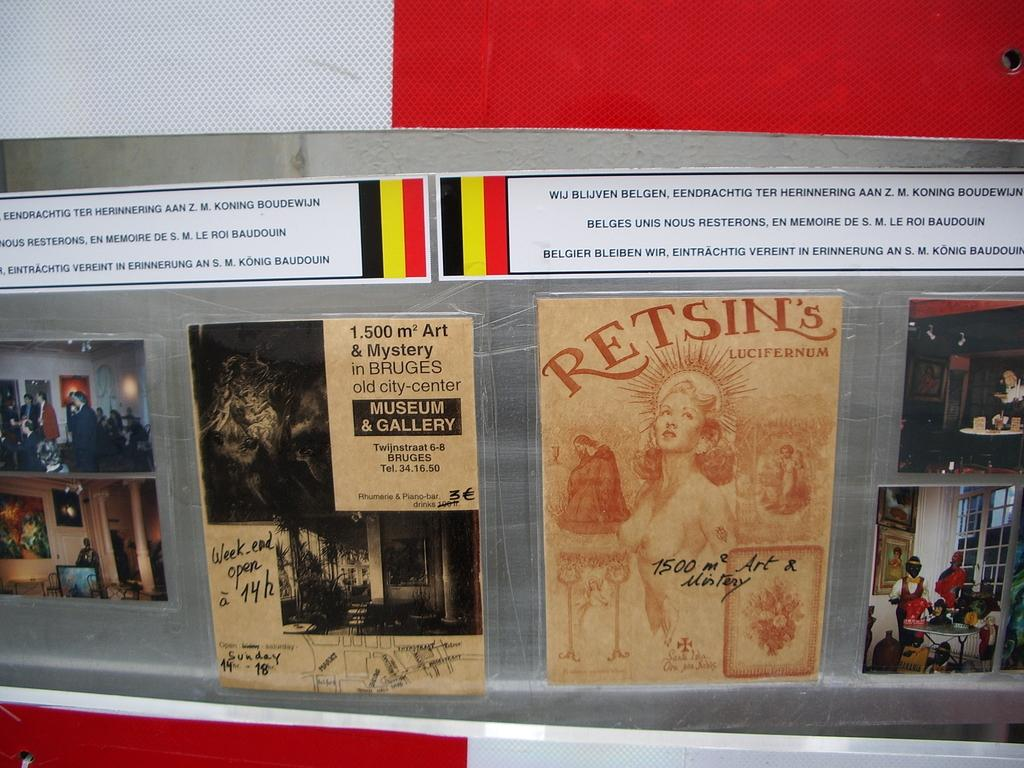<image>
Share a concise interpretation of the image provided. Several posters are displayed, including one for Retsin's Lucifernum. 